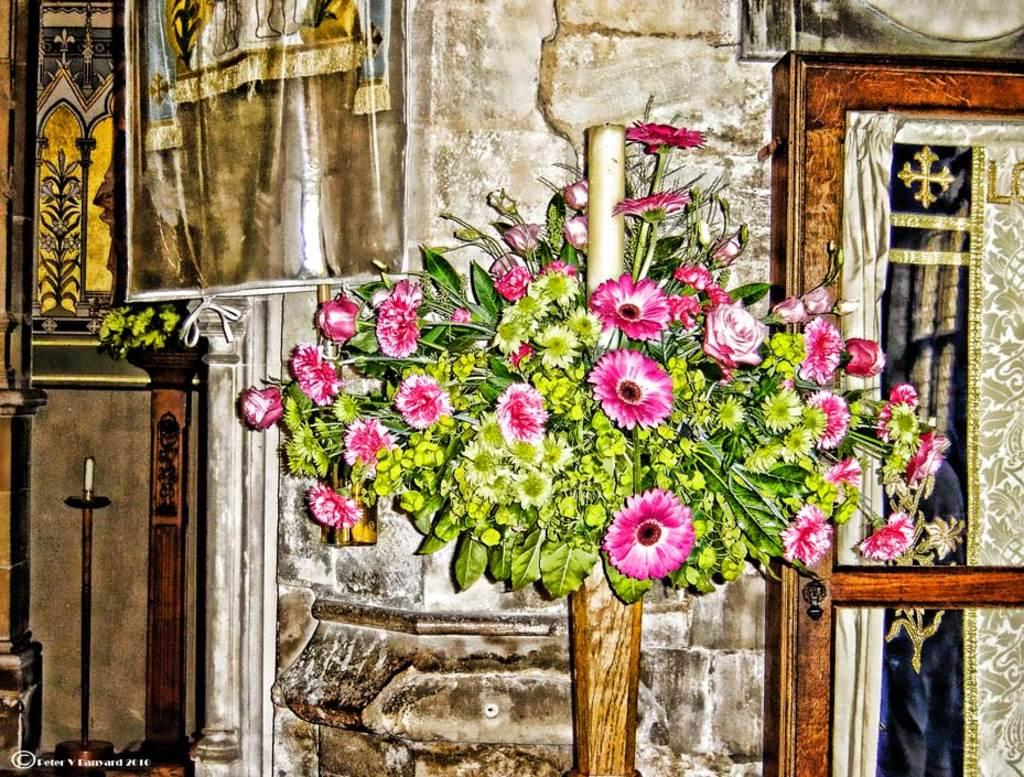What is the main subject of the image? The main subject of the image is a flower bouquet. How is the flower bouquet positioned in the image? The flower bouquet is attached to the wall. What other decorative items can be seen in the image? There are banners and candle stands in the image. What is another object attached to the wall in the image? There is a mirror attached to the wall in the image. What type of coil is used to hold the banners in the image? There is no coil present in the image; the banners are not held by any visible coil. 